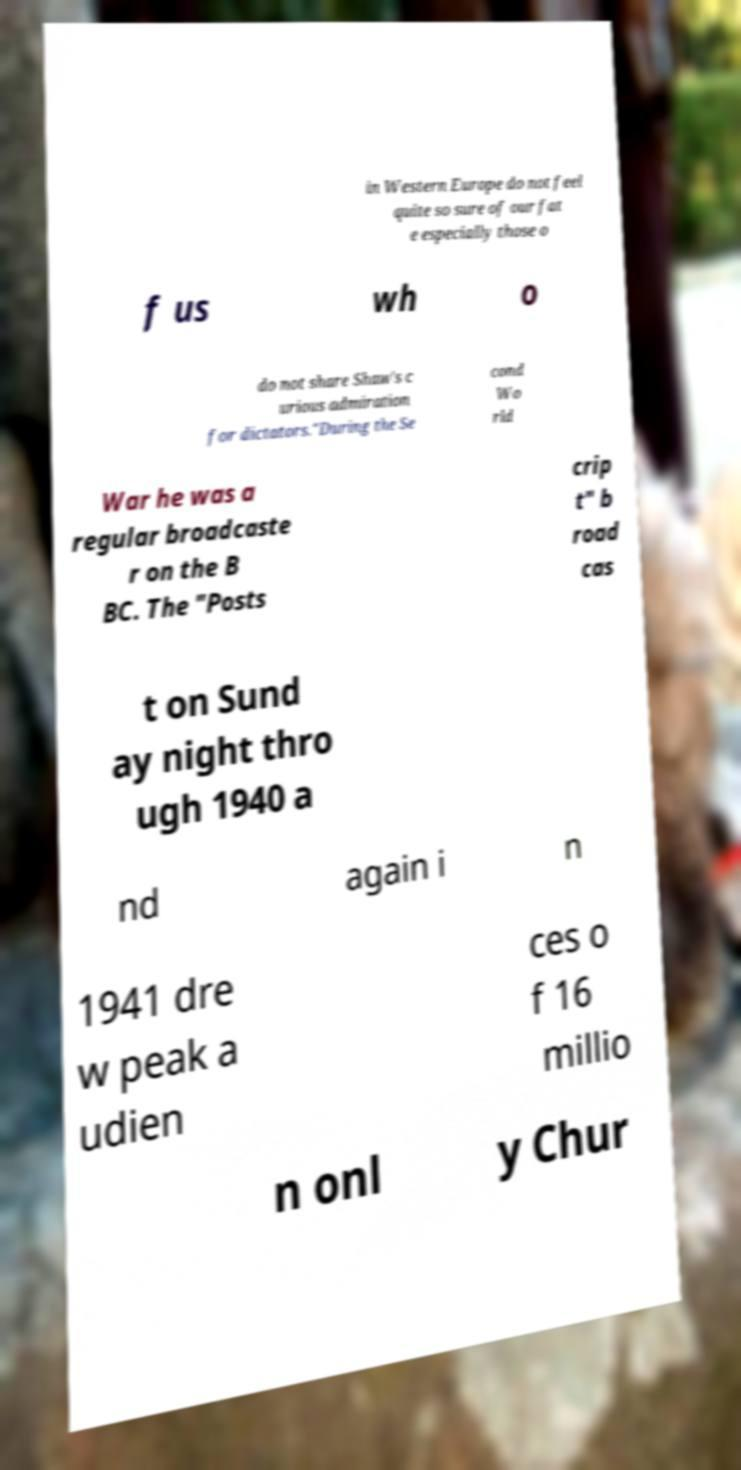Could you assist in decoding the text presented in this image and type it out clearly? in Western Europe do not feel quite so sure of our fat e especially those o f us wh o do not share Shaw's c urious admiration for dictators."During the Se cond Wo rld War he was a regular broadcaste r on the B BC. The "Posts crip t" b road cas t on Sund ay night thro ugh 1940 a nd again i n 1941 dre w peak a udien ces o f 16 millio n onl y Chur 